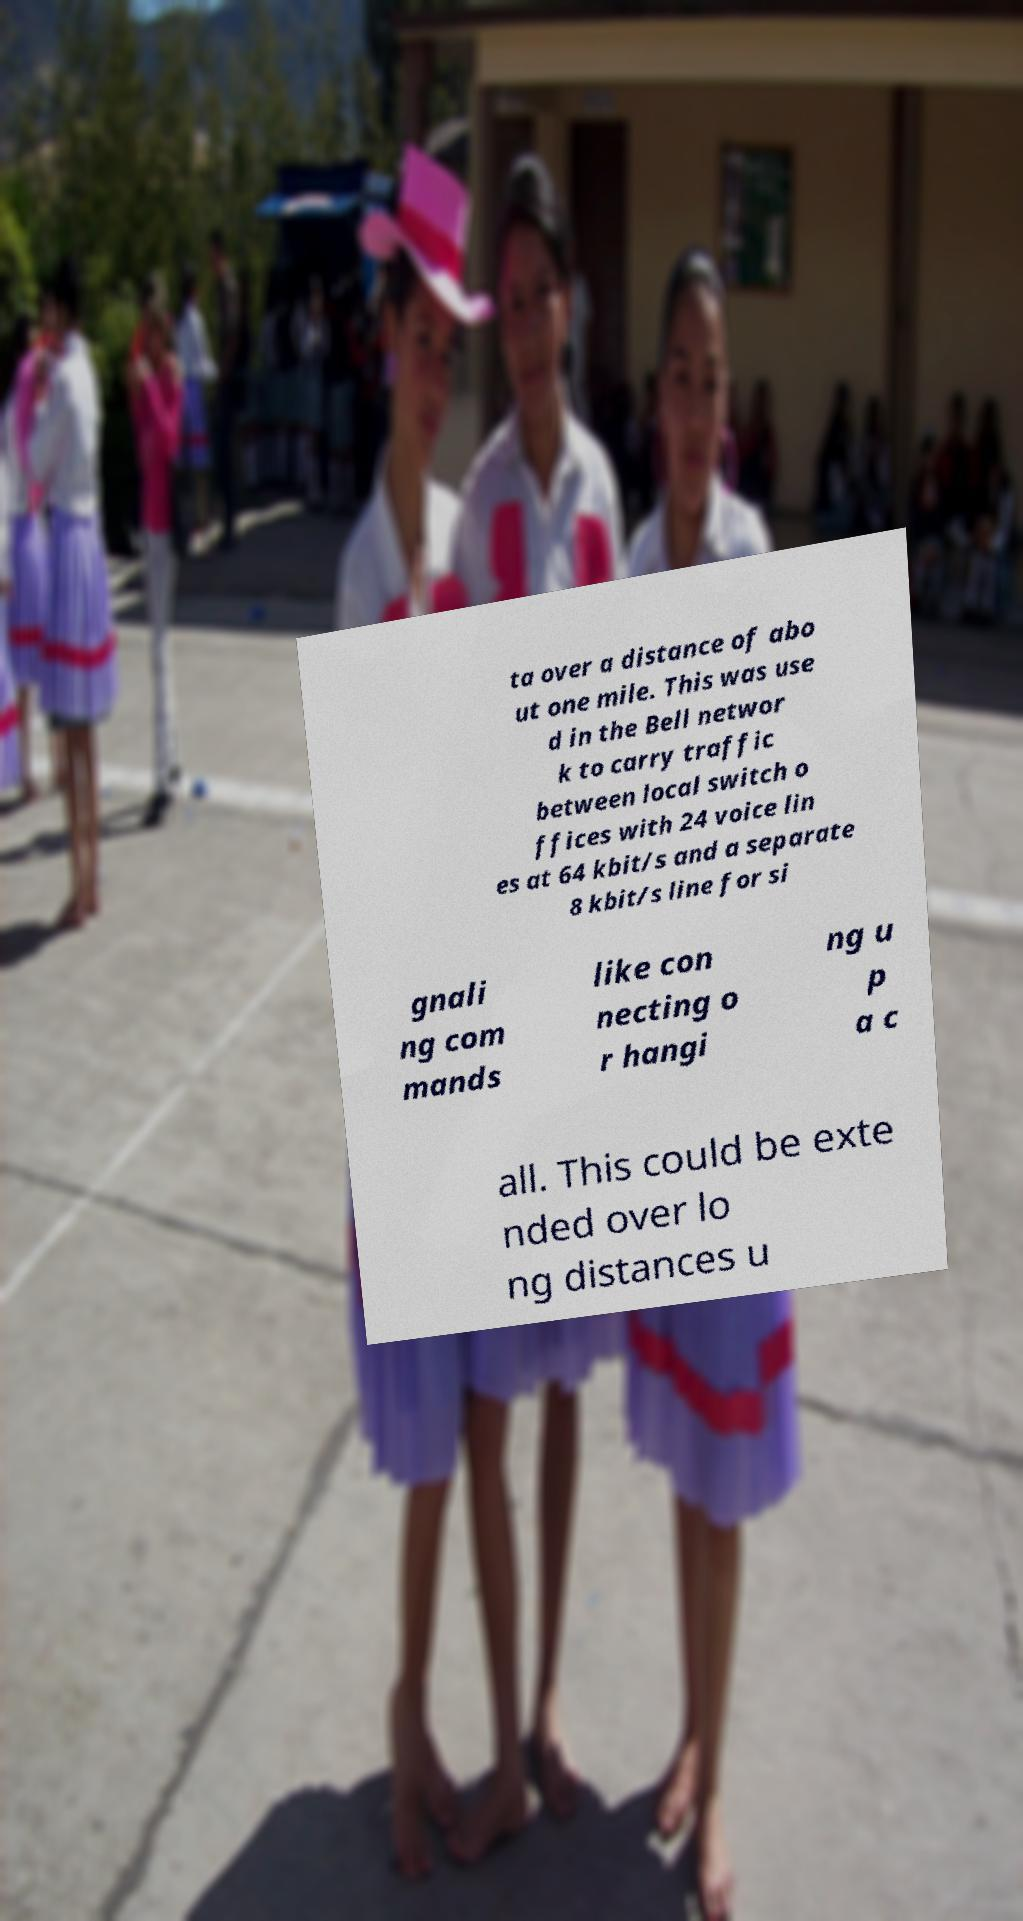Can you read and provide the text displayed in the image?This photo seems to have some interesting text. Can you extract and type it out for me? ta over a distance of abo ut one mile. This was use d in the Bell networ k to carry traffic between local switch o ffices with 24 voice lin es at 64 kbit/s and a separate 8 kbit/s line for si gnali ng com mands like con necting o r hangi ng u p a c all. This could be exte nded over lo ng distances u 